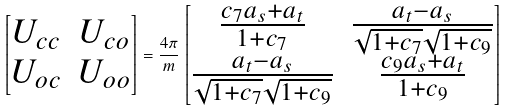Convert formula to latex. <formula><loc_0><loc_0><loc_500><loc_500>\begin{bmatrix} U _ { c c } & U _ { c o } \\ U _ { o c } & U _ { o o } \end{bmatrix} = \frac { 4 \pi } { m } \begin{bmatrix} \frac { c _ { 7 } a _ { s } + a _ { t } } { 1 + c _ { 7 } } & \frac { a _ { t } - a _ { s } } { \sqrt { 1 + c _ { 7 } } \sqrt { 1 + c _ { 9 } } } \\ \frac { a _ { t } - a _ { s } } { \sqrt { 1 + c _ { 7 } } \sqrt { 1 + c _ { 9 } } } & \frac { c _ { 9 } a _ { s } + a _ { t } } { 1 + c _ { 9 } } \end{bmatrix}</formula> 